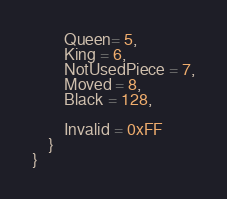Convert code to text. <code><loc_0><loc_0><loc_500><loc_500><_C#_>        Queen= 5,
        King = 6,
        NotUsedPiece = 7,
        Moved = 8,
        Black = 128,

        Invalid = 0xFF
    }
}</code> 